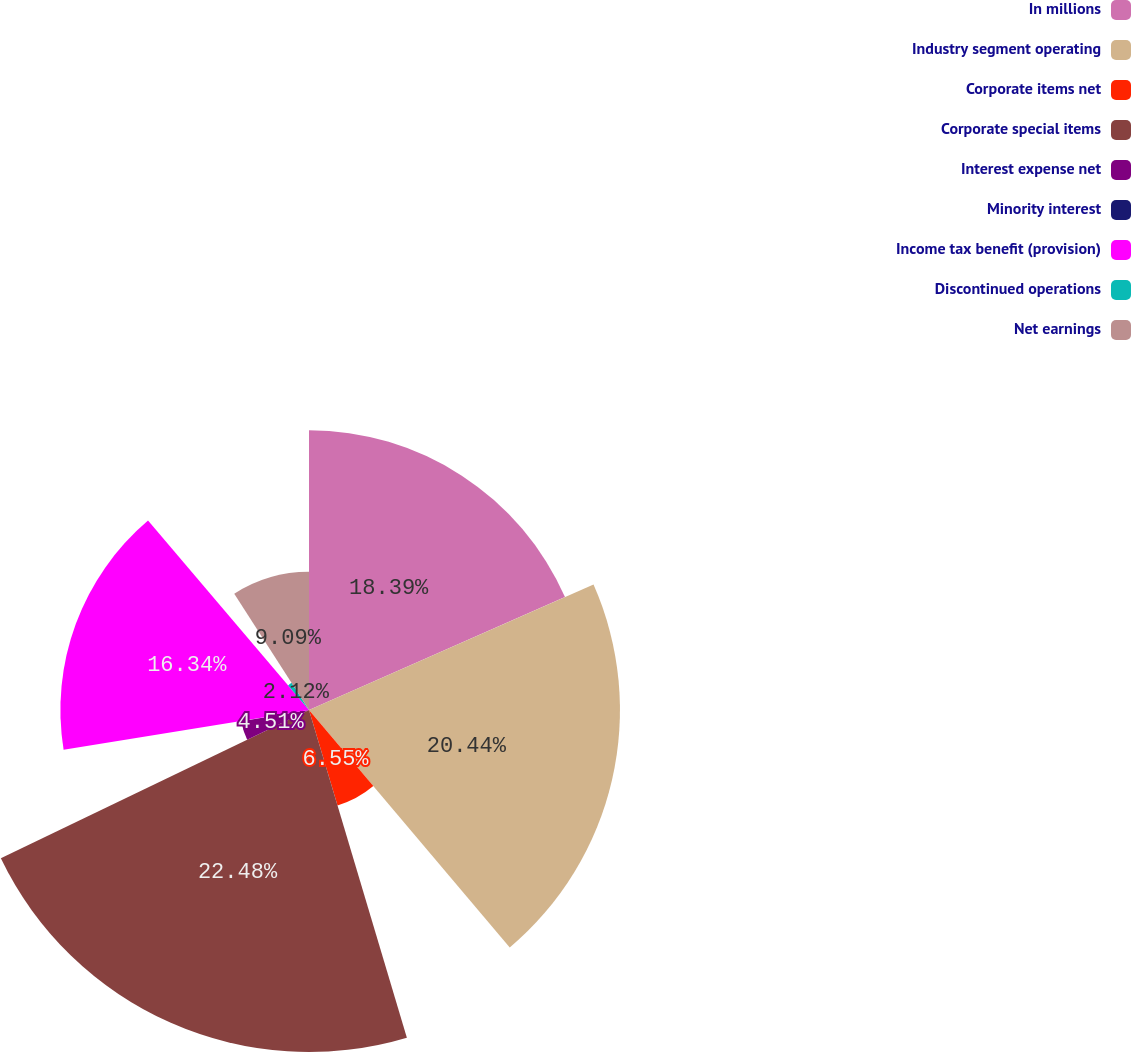Convert chart to OTSL. <chart><loc_0><loc_0><loc_500><loc_500><pie_chart><fcel>In millions<fcel>Industry segment operating<fcel>Corporate items net<fcel>Corporate special items<fcel>Interest expense net<fcel>Minority interest<fcel>Income tax benefit (provision)<fcel>Discontinued operations<fcel>Net earnings<nl><fcel>18.39%<fcel>20.44%<fcel>6.55%<fcel>22.48%<fcel>4.51%<fcel>0.08%<fcel>16.34%<fcel>2.12%<fcel>9.09%<nl></chart> 